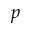<formula> <loc_0><loc_0><loc_500><loc_500>p</formula> 